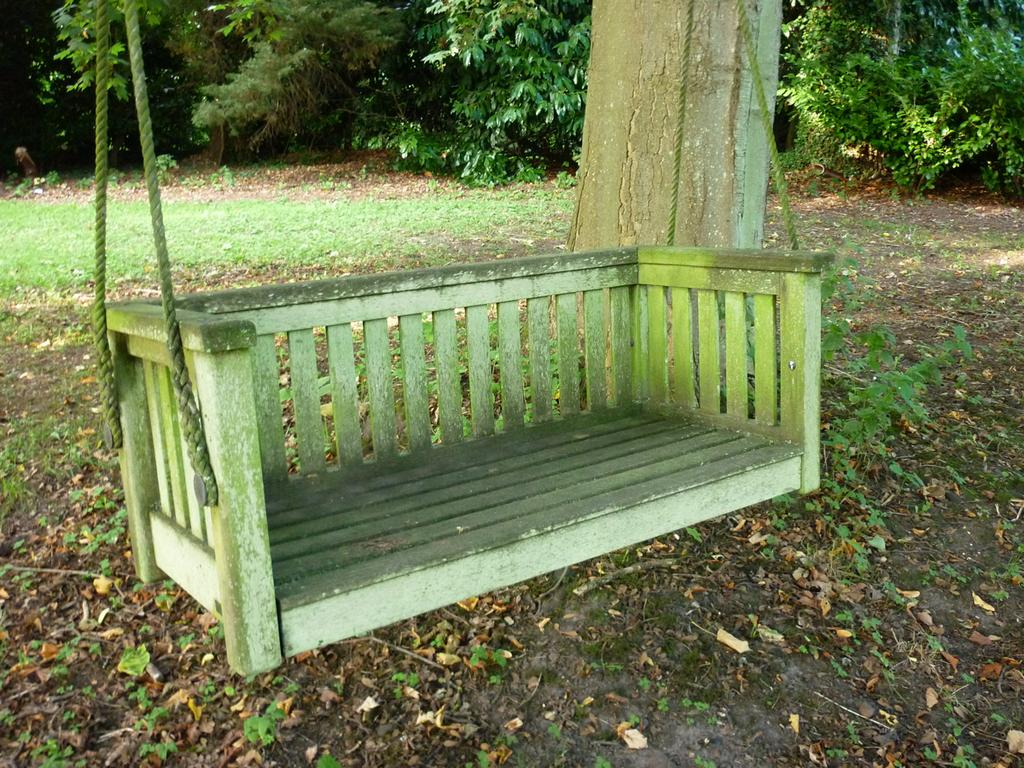What is the main object in the center of the image? There is a wooden swing in the center of the image. What can be seen in the background of the image? There are trees in the background of the image. What is visible at the bottom of the image? The ground is visible at the bottom of the image. What is present on the ground in the image? Leaves and plants are present on the ground. What type of clouds can be seen in the image? There are no clouds visible in the image; it only shows a wooden swing, trees, the ground, leaves, and plants. 